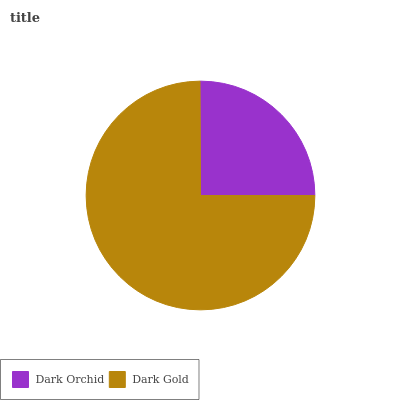Is Dark Orchid the minimum?
Answer yes or no. Yes. Is Dark Gold the maximum?
Answer yes or no. Yes. Is Dark Gold the minimum?
Answer yes or no. No. Is Dark Gold greater than Dark Orchid?
Answer yes or no. Yes. Is Dark Orchid less than Dark Gold?
Answer yes or no. Yes. Is Dark Orchid greater than Dark Gold?
Answer yes or no. No. Is Dark Gold less than Dark Orchid?
Answer yes or no. No. Is Dark Gold the high median?
Answer yes or no. Yes. Is Dark Orchid the low median?
Answer yes or no. Yes. Is Dark Orchid the high median?
Answer yes or no. No. Is Dark Gold the low median?
Answer yes or no. No. 